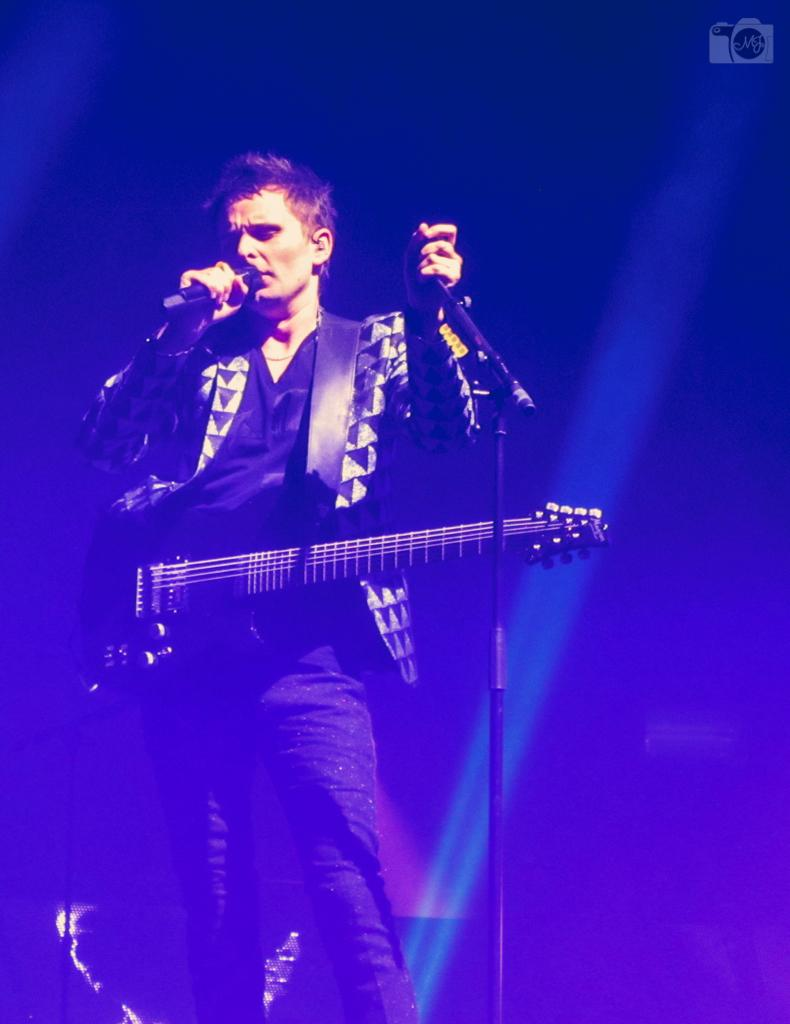What is the man in the image doing? The man is singing a song in the image. How is the man amplifying his voice? The man is using a microphone, which is on a stand. What instrument is the man playing? The man is holding a guitar. What type of setting is the man performing in? The scene appears to be a stage performance. How many kittens are playing with the microphone stand in the image? There are no kittens present in the image. What trick is the man performing with the guitar in the image? The man is not performing any tricks with the guitar in the image; he is simply playing it while singing. 